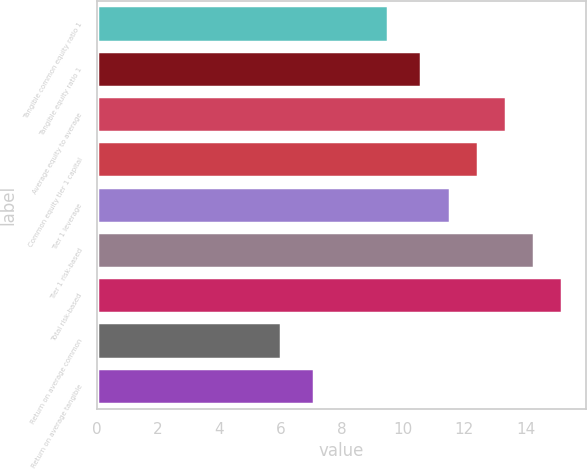<chart> <loc_0><loc_0><loc_500><loc_500><bar_chart><fcel>Tangible common equity ratio 1<fcel>Tangible equity ratio 1<fcel>Average equity to average<fcel>Common equity tier 1 capital<fcel>Tier 1 leverage<fcel>Tier 1 risk-based<fcel>Total risk-based<fcel>Return on average common<fcel>Return on average tangible<nl><fcel>9.5<fcel>10.6<fcel>13.36<fcel>12.44<fcel>11.52<fcel>14.28<fcel>15.2<fcel>6<fcel>7.1<nl></chart> 